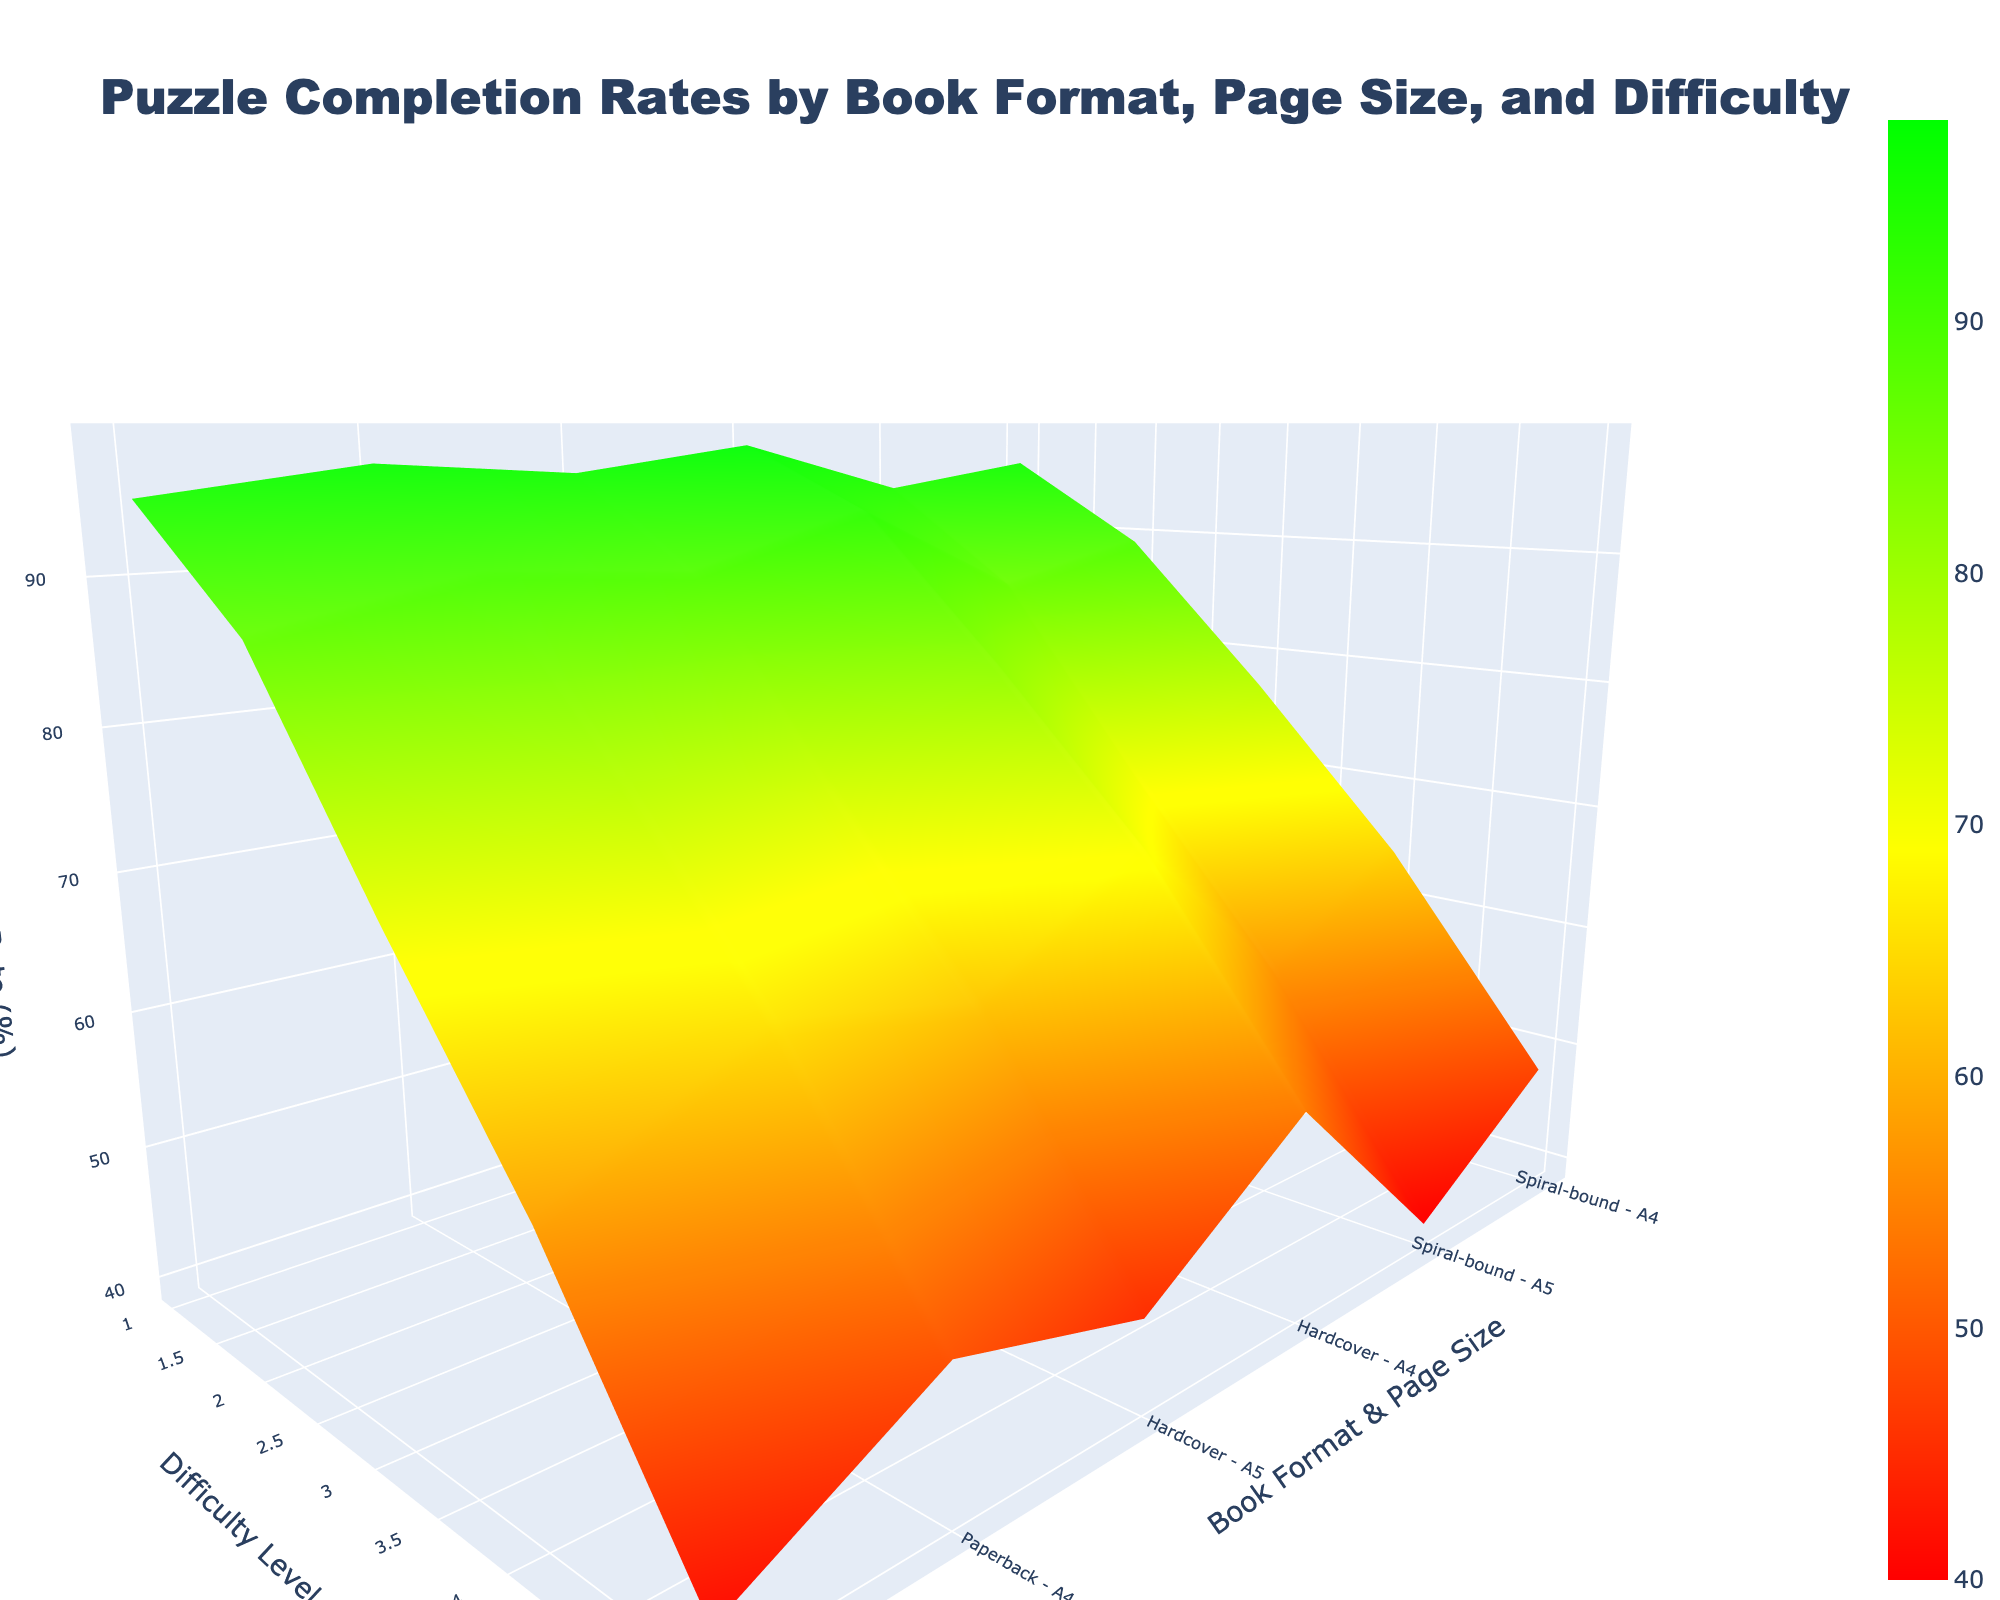What is the title of the plot? The title is usually located at the top of the figure. In this plot, it is found in the layout settings.
Answer: Puzzle Completion Rates by Book Format, Page Size, and Difficulty How is the x-axis labeled? The x-axis label is set by the 'xaxis_title' attribute in the layout settings.
Answer: Difficulty Level Which book format and page size combination has the highest completion rate for difficulty level 3? Identify the highest z-value (completion rate) by finding the peak on the surface corresponding to difficulty level 3. The highest value should occur for the best-performing format and size.
Answer: Hardcover - A4 Which combination has the lowest completion rate overall? Observe the lowest point on the surface plot. This will be the format and size with the minimum z-value (completion rate).
Answer: Spiral-bound - A5 How do completion rates generally trend as difficulty levels increase? Notice the slope and shape of the surface. A decreasing trend would show a downward slope.
Answer: They decrease What is the average completion rate for Paperback books at difficulty level 2? Identify the completion rates for Paperback books at difficulty level 2 from both A5 and A4 page sizes, then calculate their average. (87 + 90) / 2 = 88.5%
Answer: 88.5% How does the completion rate for Spiral-bound books of A5 size change from difficulty level 1 to 5? Track the completion rates for Spiral-bound books with A5 size at each difficulty level, noting their pattern. 94, 86, 71, 57, 40 - the rate decreases.
Answer: The completion rate decreases Which has a higher completion rate for difficulty level 4, Hardcover - A5 or Spiral-bound - A4? Compare the completion rates for difficulty level 4 across these two combinations directly from the plot or data.
Answer: Spiral-bound - A4 By what percentage does the completion rate of Hardcover - A4 decrease from difficulty level 1 to difficulty level 5? Calculate the difference in rates for Hardcover - A4 at these levels, then convert the difference to a percentage of the initial rate: ((98 - 54) / 98) * 100%.
Answer: 44.9% What pattern do you observe in the completion rates for books with A4 page size compared to A5 across all difficulty levels? Compare the surface plots for A4 and A5 sizes across all book formats, noting general trends in height and slope.
Answer: A4 completion rates are generally higher than A5 across all difficulty levels 